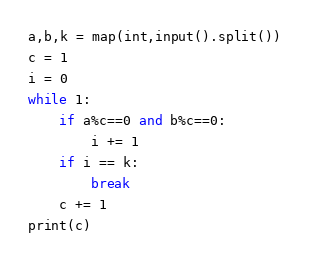<code> <loc_0><loc_0><loc_500><loc_500><_Python_>a,b,k = map(int,input().split())
c = 1
i = 0
while 1:
    if a%c==0 and b%c==0:
        i += 1
    if i == k:
        break
    c += 1
print(c)</code> 